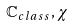Convert formula to latex. <formula><loc_0><loc_0><loc_500><loc_500>\mathbb { C } _ { c l a s s } , \chi</formula> 